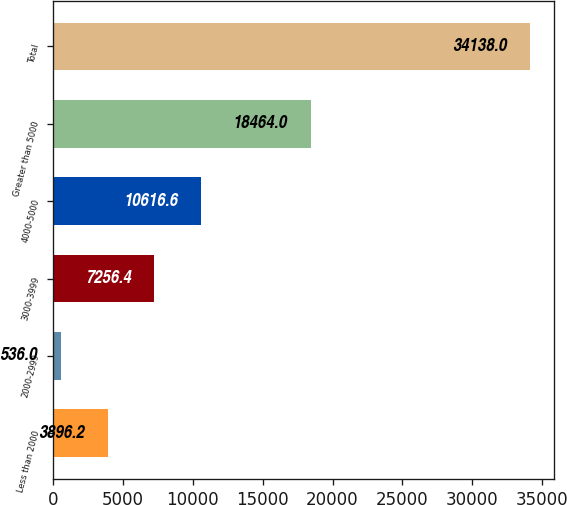Convert chart. <chart><loc_0><loc_0><loc_500><loc_500><bar_chart><fcel>Less than 2000<fcel>2000-2999<fcel>3000-3999<fcel>4000-5000<fcel>Greater than 5000<fcel>Total<nl><fcel>3896.2<fcel>536<fcel>7256.4<fcel>10616.6<fcel>18464<fcel>34138<nl></chart> 